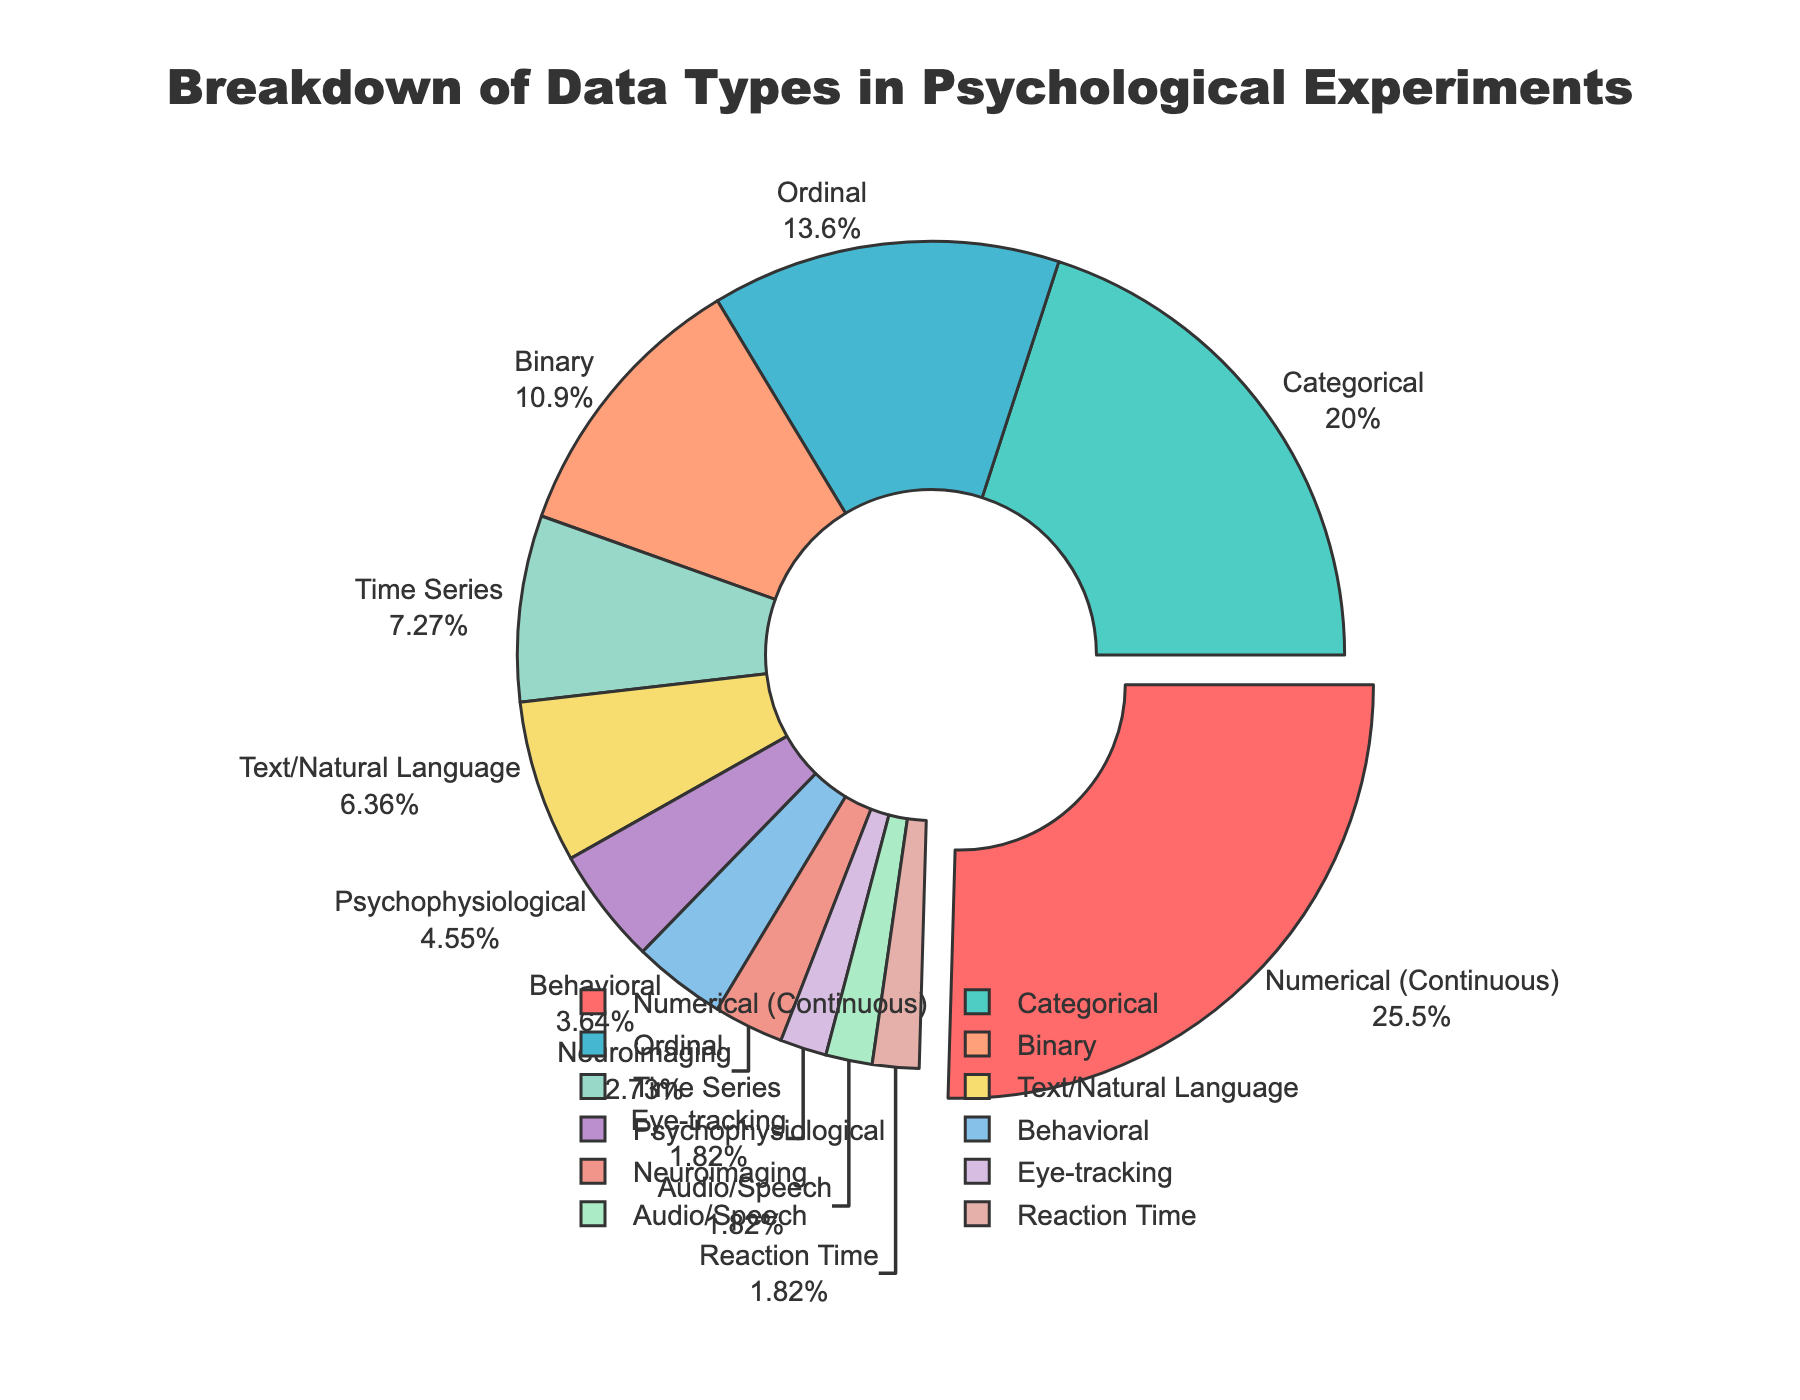Which data type is most commonly used in psychological experiments? The pie chart shows the breakdown of various data types used in psychological experiments. The data type with the largest percentage is the most common.
Answer: Numerical (Continuous) What is the combined percentage of Categorical and Binary data types? To find the combined percentage, add the individual percentages of Categorical (22%) and Binary (12%) data types.
Answer: 34% How much less is the percentage of Text/Natural Language data compared to Numerical (Continuous) data? Subtract the percentage of Text/Natural Language (7%) from Numerical (Continuous) (28%).
Answer: 21% Which data type has the second smallest percentage? The pie chart shows different data types and their percentages. The second smallest percentage is slightly larger than the smallest.
Answer: Eye-tracking Are there more data points in Neuroimaging than in Audio/Speech? Compare the percentages of Neuroimaging (3%) and Audio/Speech (2%) data types.
Answer: Yes What is the average percentage of Binary, Text/Natural Language, and Psychophysiological data types? Add the percentages of Binary (12%), Text/Natural Language (7%), and Psychophysiological (5%), then divide by the number of data types (3). (12 + 7 + 5) / 3 = 8
Answer: 8% What is the difference in percentage between Ordinal and Time Series data types? Subtract the percentage of Time Series (8%) from Ordinal (15%).
Answer: 7% Identify the data types that together account for 10% of the total data. The pie chart shows data types with their percentages. Identify and add those that total 10%, i.e., Eye-tracking (2%), Audio/Speech (2%), Reaction Time (2%), and Behavioral (4%).
Answer: Eye-tracking, Audio/Speech, Reaction Time, Behavioral Which data type is highlighted (pulled) in the pie chart? The largest data type section is usually pulled out to highlight it. In this pie chart, the Numerical (Continuous) section appears to be pulled.
Answer: Numerical (Continuous) How many data types have a percentage value in the single digits? Count the data types with a percentage less than 10%.
Answer: 7 